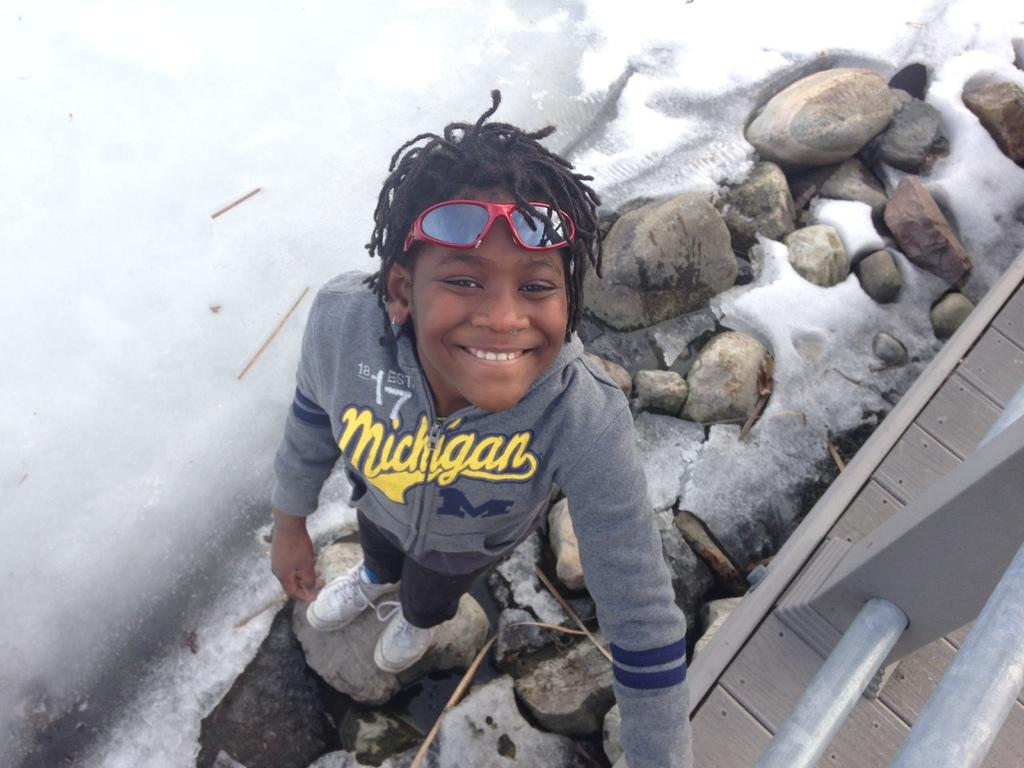Who is in the picture? There is a boy in the picture. What is the boy doing in the picture? The boy is standing and smiling. What can be seen in the background of the picture? There is railing and stones in the picture. What is the weather like in the picture? There is snow in the picture, indicating a cold or wintery setting. How many rabbits are hopping around the boy in the picture? There are no rabbits present in the image. What type of boot is the boy wearing in the picture? The image does not show the boy wearing any boots, so it cannot be determined from the picture. 